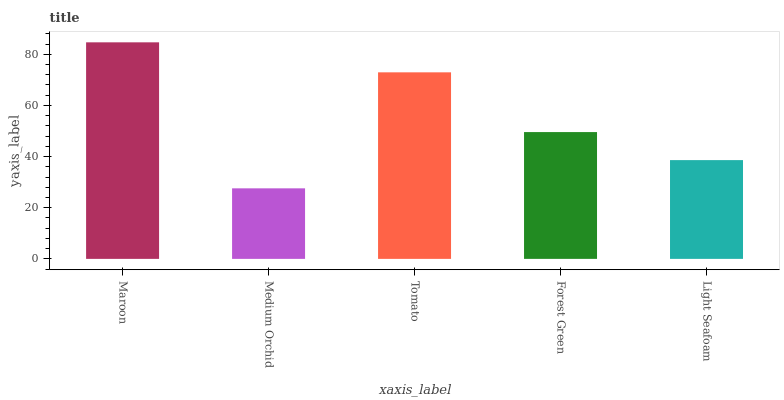Is Tomato the minimum?
Answer yes or no. No. Is Tomato the maximum?
Answer yes or no. No. Is Tomato greater than Medium Orchid?
Answer yes or no. Yes. Is Medium Orchid less than Tomato?
Answer yes or no. Yes. Is Medium Orchid greater than Tomato?
Answer yes or no. No. Is Tomato less than Medium Orchid?
Answer yes or no. No. Is Forest Green the high median?
Answer yes or no. Yes. Is Forest Green the low median?
Answer yes or no. Yes. Is Maroon the high median?
Answer yes or no. No. Is Maroon the low median?
Answer yes or no. No. 